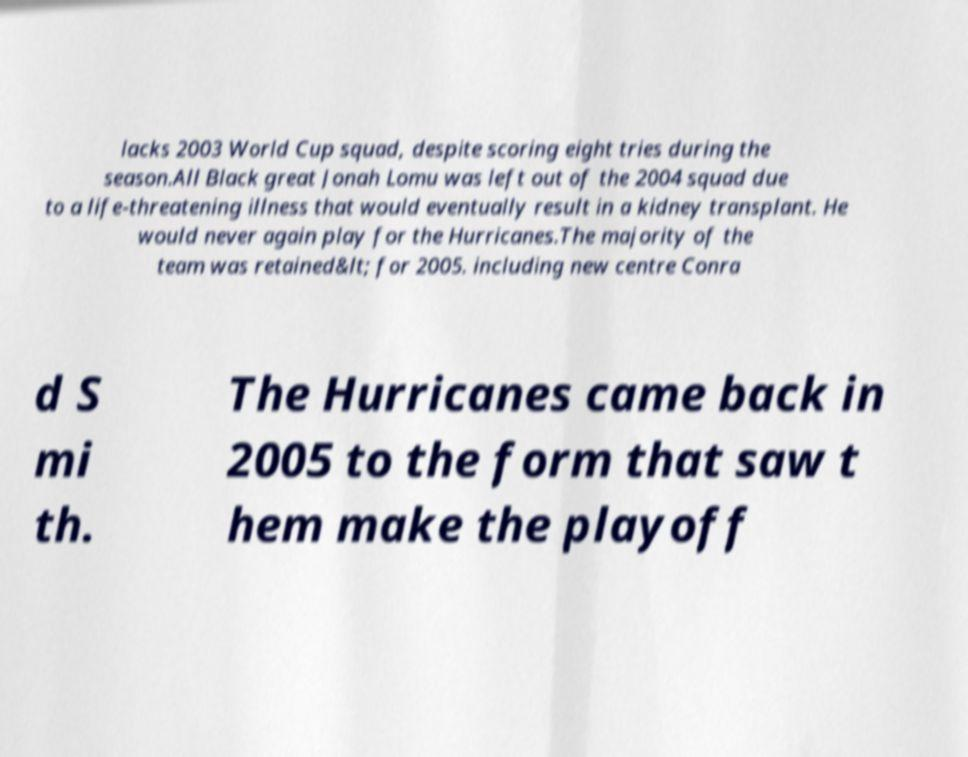What messages or text are displayed in this image? I need them in a readable, typed format. lacks 2003 World Cup squad, despite scoring eight tries during the season.All Black great Jonah Lomu was left out of the 2004 squad due to a life-threatening illness that would eventually result in a kidney transplant. He would never again play for the Hurricanes.The majority of the team was retained&lt; for 2005. including new centre Conra d S mi th. The Hurricanes came back in 2005 to the form that saw t hem make the playoff 